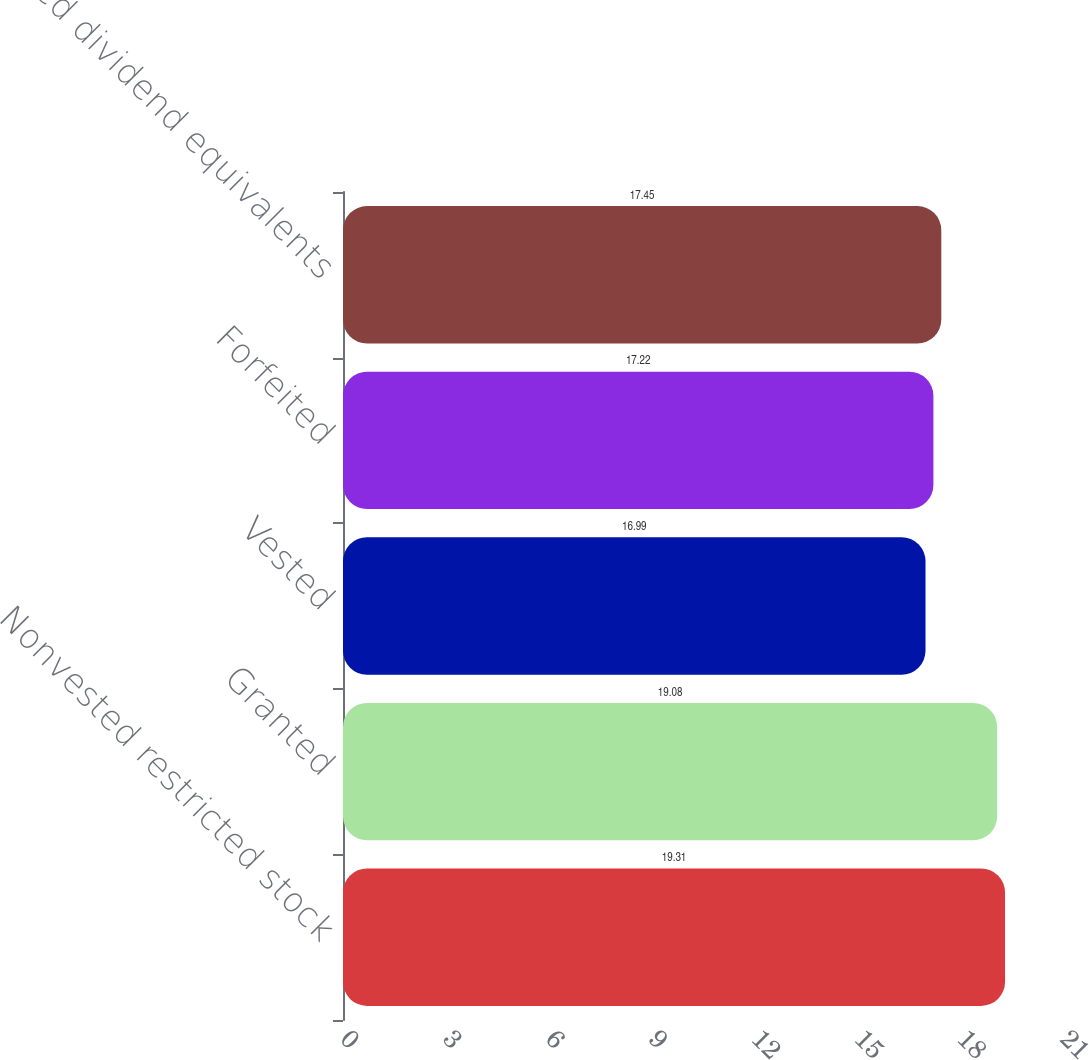Convert chart. <chart><loc_0><loc_0><loc_500><loc_500><bar_chart><fcel>Nonvested restricted stock<fcel>Granted<fcel>Vested<fcel>Forfeited<fcel>Earned dividend equivalents<nl><fcel>19.31<fcel>19.08<fcel>16.99<fcel>17.22<fcel>17.45<nl></chart> 